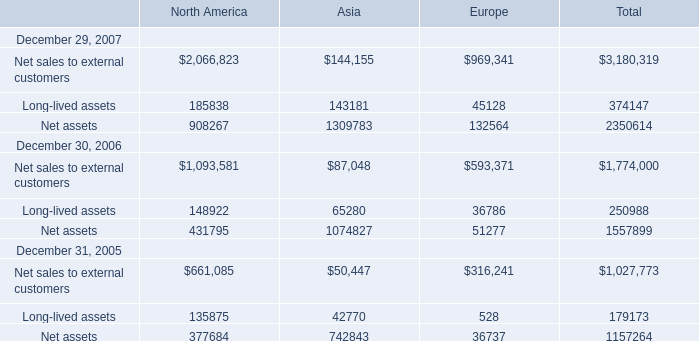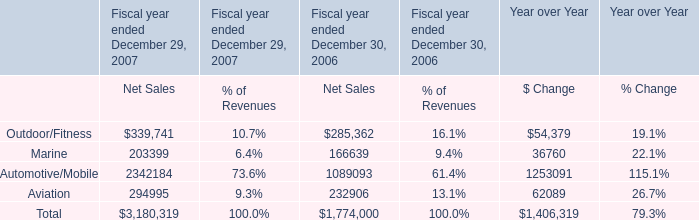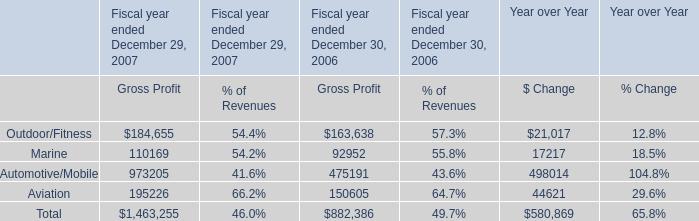What was the sum of elements for North America without those elements smaller than 200000 in 2007? 
Computations: (2066823 + 908267)
Answer: 2975090.0. 